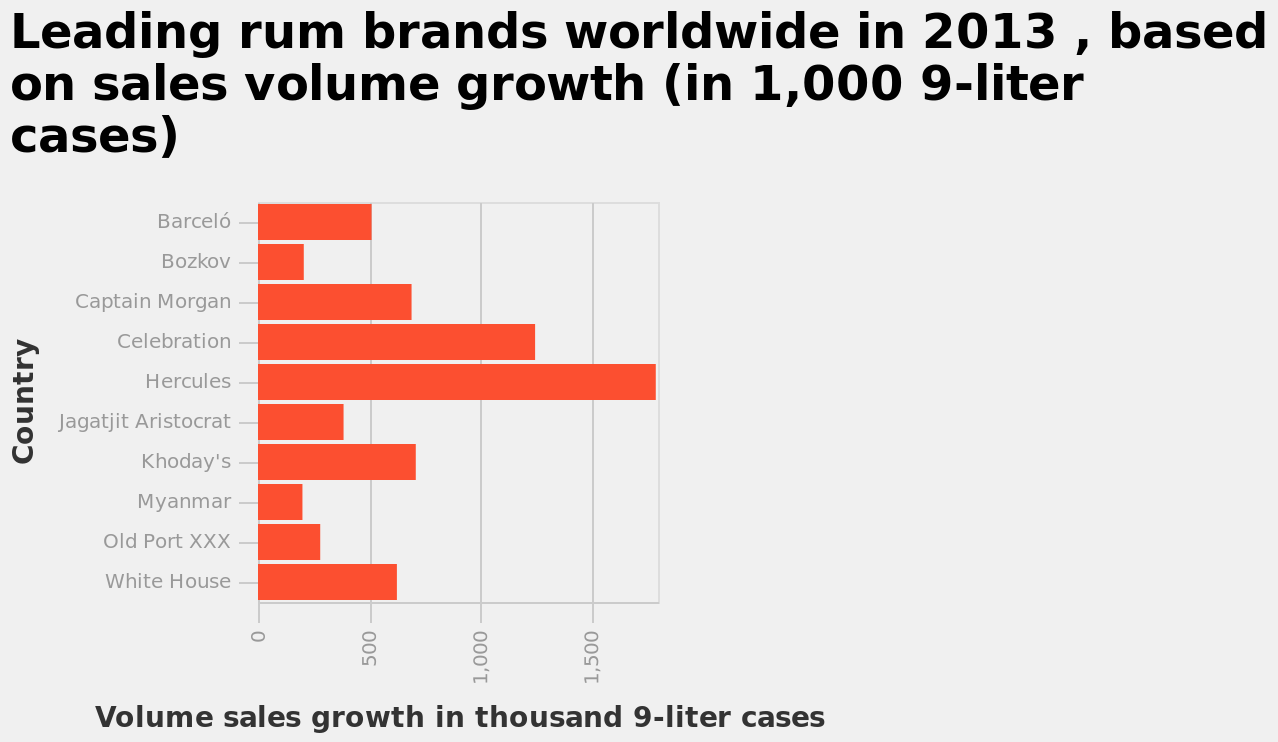<image>
Describe the following image in detail This bar diagram is titled Leading rum brands worldwide in 2013 , based on sales volume growth (in 1,000 9-liter cases). The x-axis measures Volume sales growth in thousand 9-liter cases while the y-axis plots Country. What is the difference in growth between Hercules and Bozkov? The difference in growth between Hercules and Bozkov is more than 1300 cases. Offer a thorough analysis of the image. Hércules is the most sold rum brand at approximately 1750 units. Myanmar and Bozkov sold similar amounts. Myanmar and Bozkov sold the least number of units. Five of the ten brands sold over 500 units. What year does the bar diagram represent? The bar diagram represents the year 2013. Is the y-axis measuring Volume sales growth in thousand 9-liter cases while the x-axis plots Country? No.This bar diagram is titled Leading rum brands worldwide in 2013 , based on sales volume growth (in 1,000 9-liter cases). The x-axis measures Volume sales growth in thousand 9-liter cases while the y-axis plots Country. 